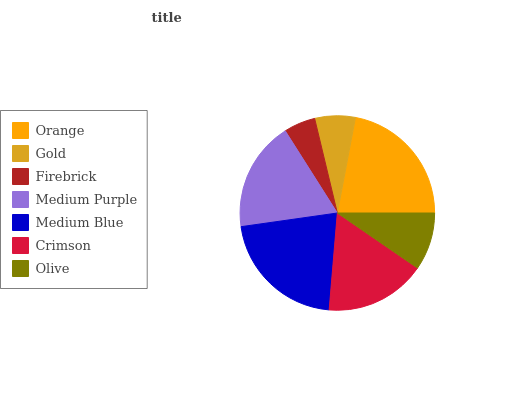Is Firebrick the minimum?
Answer yes or no. Yes. Is Orange the maximum?
Answer yes or no. Yes. Is Gold the minimum?
Answer yes or no. No. Is Gold the maximum?
Answer yes or no. No. Is Orange greater than Gold?
Answer yes or no. Yes. Is Gold less than Orange?
Answer yes or no. Yes. Is Gold greater than Orange?
Answer yes or no. No. Is Orange less than Gold?
Answer yes or no. No. Is Crimson the high median?
Answer yes or no. Yes. Is Crimson the low median?
Answer yes or no. Yes. Is Olive the high median?
Answer yes or no. No. Is Medium Purple the low median?
Answer yes or no. No. 